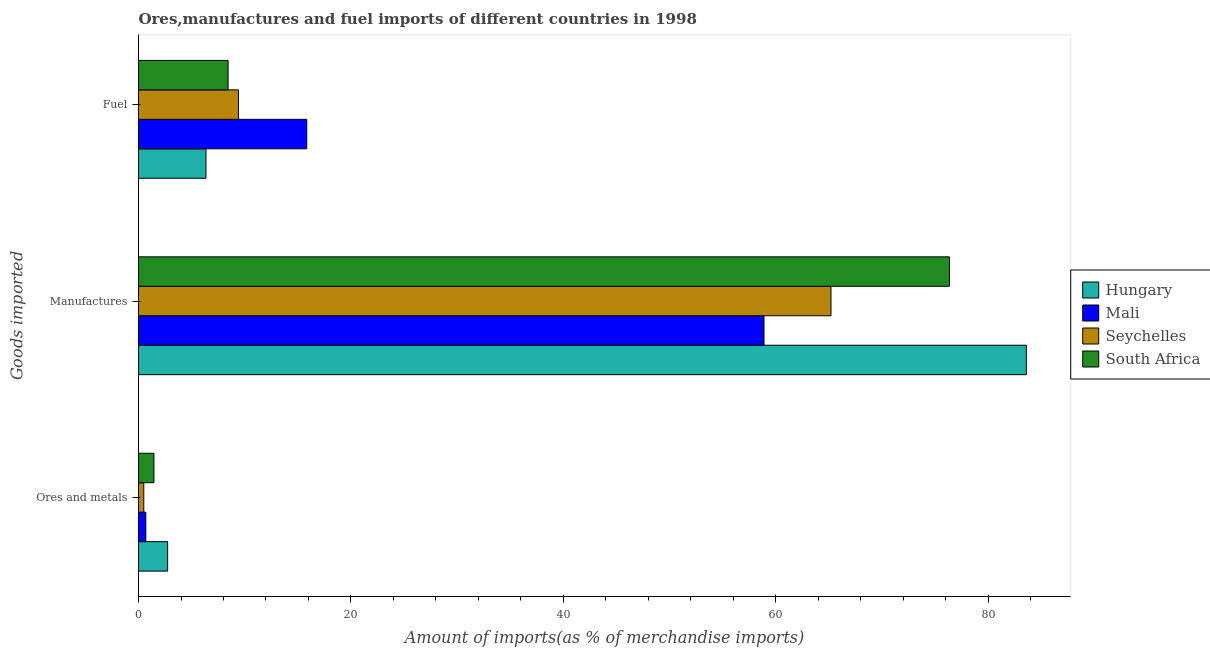Are the number of bars per tick equal to the number of legend labels?
Give a very brief answer. Yes. Are the number of bars on each tick of the Y-axis equal?
Provide a short and direct response. Yes. How many bars are there on the 3rd tick from the bottom?
Ensure brevity in your answer.  4. What is the label of the 1st group of bars from the top?
Provide a succinct answer. Fuel. What is the percentage of fuel imports in Mali?
Your answer should be very brief. 15.84. Across all countries, what is the maximum percentage of fuel imports?
Make the answer very short. 15.84. Across all countries, what is the minimum percentage of manufactures imports?
Your response must be concise. 58.89. In which country was the percentage of ores and metals imports maximum?
Offer a very short reply. Hungary. In which country was the percentage of fuel imports minimum?
Your response must be concise. Hungary. What is the total percentage of fuel imports in the graph?
Make the answer very short. 40.03. What is the difference between the percentage of manufactures imports in Seychelles and that in Hungary?
Offer a very short reply. -18.39. What is the difference between the percentage of fuel imports in South Africa and the percentage of ores and metals imports in Seychelles?
Your answer should be very brief. 7.94. What is the average percentage of ores and metals imports per country?
Offer a very short reply. 1.34. What is the difference between the percentage of ores and metals imports and percentage of fuel imports in Hungary?
Ensure brevity in your answer.  -3.61. What is the ratio of the percentage of fuel imports in Hungary to that in Mali?
Provide a short and direct response. 0.4. What is the difference between the highest and the second highest percentage of manufactures imports?
Make the answer very short. 7.24. What is the difference between the highest and the lowest percentage of ores and metals imports?
Provide a succinct answer. 2.24. In how many countries, is the percentage of fuel imports greater than the average percentage of fuel imports taken over all countries?
Your response must be concise. 1. What does the 4th bar from the top in Fuel represents?
Make the answer very short. Hungary. What does the 4th bar from the bottom in Manufactures represents?
Offer a terse response. South Africa. Is it the case that in every country, the sum of the percentage of ores and metals imports and percentage of manufactures imports is greater than the percentage of fuel imports?
Keep it short and to the point. Yes. How many bars are there?
Offer a terse response. 12. How many countries are there in the graph?
Keep it short and to the point. 4. What is the difference between two consecutive major ticks on the X-axis?
Make the answer very short. 20. Where does the legend appear in the graph?
Give a very brief answer. Center right. How many legend labels are there?
Give a very brief answer. 4. How are the legend labels stacked?
Your answer should be compact. Vertical. What is the title of the graph?
Offer a very short reply. Ores,manufactures and fuel imports of different countries in 1998. Does "Arab World" appear as one of the legend labels in the graph?
Your response must be concise. No. What is the label or title of the X-axis?
Provide a short and direct response. Amount of imports(as % of merchandise imports). What is the label or title of the Y-axis?
Provide a short and direct response. Goods imported. What is the Amount of imports(as % of merchandise imports) in Hungary in Ores and metals?
Give a very brief answer. 2.74. What is the Amount of imports(as % of merchandise imports) in Mali in Ores and metals?
Your answer should be compact. 0.69. What is the Amount of imports(as % of merchandise imports) of Seychelles in Ores and metals?
Offer a terse response. 0.5. What is the Amount of imports(as % of merchandise imports) in South Africa in Ores and metals?
Offer a terse response. 1.45. What is the Amount of imports(as % of merchandise imports) in Hungary in Manufactures?
Keep it short and to the point. 83.59. What is the Amount of imports(as % of merchandise imports) in Mali in Manufactures?
Provide a short and direct response. 58.89. What is the Amount of imports(as % of merchandise imports) in Seychelles in Manufactures?
Your answer should be very brief. 65.19. What is the Amount of imports(as % of merchandise imports) of South Africa in Manufactures?
Offer a very short reply. 76.35. What is the Amount of imports(as % of merchandise imports) in Hungary in Fuel?
Give a very brief answer. 6.35. What is the Amount of imports(as % of merchandise imports) in Mali in Fuel?
Provide a succinct answer. 15.84. What is the Amount of imports(as % of merchandise imports) of Seychelles in Fuel?
Your answer should be compact. 9.41. What is the Amount of imports(as % of merchandise imports) in South Africa in Fuel?
Provide a succinct answer. 8.43. Across all Goods imported, what is the maximum Amount of imports(as % of merchandise imports) of Hungary?
Offer a very short reply. 83.59. Across all Goods imported, what is the maximum Amount of imports(as % of merchandise imports) in Mali?
Offer a terse response. 58.89. Across all Goods imported, what is the maximum Amount of imports(as % of merchandise imports) of Seychelles?
Offer a terse response. 65.19. Across all Goods imported, what is the maximum Amount of imports(as % of merchandise imports) of South Africa?
Your answer should be very brief. 76.35. Across all Goods imported, what is the minimum Amount of imports(as % of merchandise imports) of Hungary?
Your response must be concise. 2.74. Across all Goods imported, what is the minimum Amount of imports(as % of merchandise imports) in Mali?
Your answer should be very brief. 0.69. Across all Goods imported, what is the minimum Amount of imports(as % of merchandise imports) in Seychelles?
Your answer should be very brief. 0.5. Across all Goods imported, what is the minimum Amount of imports(as % of merchandise imports) in South Africa?
Your answer should be compact. 1.45. What is the total Amount of imports(as % of merchandise imports) of Hungary in the graph?
Ensure brevity in your answer.  92.68. What is the total Amount of imports(as % of merchandise imports) in Mali in the graph?
Offer a terse response. 75.42. What is the total Amount of imports(as % of merchandise imports) in Seychelles in the graph?
Offer a very short reply. 75.1. What is the total Amount of imports(as % of merchandise imports) of South Africa in the graph?
Your answer should be compact. 86.23. What is the difference between the Amount of imports(as % of merchandise imports) of Hungary in Ores and metals and that in Manufactures?
Offer a terse response. -80.84. What is the difference between the Amount of imports(as % of merchandise imports) of Mali in Ores and metals and that in Manufactures?
Provide a short and direct response. -58.2. What is the difference between the Amount of imports(as % of merchandise imports) in Seychelles in Ores and metals and that in Manufactures?
Ensure brevity in your answer.  -64.7. What is the difference between the Amount of imports(as % of merchandise imports) of South Africa in Ores and metals and that in Manufactures?
Offer a very short reply. -74.89. What is the difference between the Amount of imports(as % of merchandise imports) of Hungary in Ores and metals and that in Fuel?
Offer a terse response. -3.61. What is the difference between the Amount of imports(as % of merchandise imports) of Mali in Ores and metals and that in Fuel?
Your answer should be compact. -15.15. What is the difference between the Amount of imports(as % of merchandise imports) of Seychelles in Ores and metals and that in Fuel?
Offer a terse response. -8.91. What is the difference between the Amount of imports(as % of merchandise imports) in South Africa in Ores and metals and that in Fuel?
Your answer should be compact. -6.98. What is the difference between the Amount of imports(as % of merchandise imports) in Hungary in Manufactures and that in Fuel?
Your response must be concise. 77.23. What is the difference between the Amount of imports(as % of merchandise imports) in Mali in Manufactures and that in Fuel?
Provide a short and direct response. 43.05. What is the difference between the Amount of imports(as % of merchandise imports) in Seychelles in Manufactures and that in Fuel?
Keep it short and to the point. 55.79. What is the difference between the Amount of imports(as % of merchandise imports) of South Africa in Manufactures and that in Fuel?
Ensure brevity in your answer.  67.91. What is the difference between the Amount of imports(as % of merchandise imports) of Hungary in Ores and metals and the Amount of imports(as % of merchandise imports) of Mali in Manufactures?
Give a very brief answer. -56.15. What is the difference between the Amount of imports(as % of merchandise imports) of Hungary in Ores and metals and the Amount of imports(as % of merchandise imports) of Seychelles in Manufactures?
Keep it short and to the point. -62.45. What is the difference between the Amount of imports(as % of merchandise imports) in Hungary in Ores and metals and the Amount of imports(as % of merchandise imports) in South Africa in Manufactures?
Your answer should be very brief. -73.6. What is the difference between the Amount of imports(as % of merchandise imports) in Mali in Ores and metals and the Amount of imports(as % of merchandise imports) in Seychelles in Manufactures?
Offer a terse response. -64.51. What is the difference between the Amount of imports(as % of merchandise imports) in Mali in Ores and metals and the Amount of imports(as % of merchandise imports) in South Africa in Manufactures?
Your response must be concise. -75.66. What is the difference between the Amount of imports(as % of merchandise imports) in Seychelles in Ores and metals and the Amount of imports(as % of merchandise imports) in South Africa in Manufactures?
Your answer should be compact. -75.85. What is the difference between the Amount of imports(as % of merchandise imports) in Hungary in Ores and metals and the Amount of imports(as % of merchandise imports) in Mali in Fuel?
Your answer should be very brief. -13.1. What is the difference between the Amount of imports(as % of merchandise imports) in Hungary in Ores and metals and the Amount of imports(as % of merchandise imports) in Seychelles in Fuel?
Give a very brief answer. -6.67. What is the difference between the Amount of imports(as % of merchandise imports) in Hungary in Ores and metals and the Amount of imports(as % of merchandise imports) in South Africa in Fuel?
Keep it short and to the point. -5.69. What is the difference between the Amount of imports(as % of merchandise imports) in Mali in Ores and metals and the Amount of imports(as % of merchandise imports) in Seychelles in Fuel?
Offer a very short reply. -8.72. What is the difference between the Amount of imports(as % of merchandise imports) of Mali in Ores and metals and the Amount of imports(as % of merchandise imports) of South Africa in Fuel?
Provide a short and direct response. -7.75. What is the difference between the Amount of imports(as % of merchandise imports) in Seychelles in Ores and metals and the Amount of imports(as % of merchandise imports) in South Africa in Fuel?
Make the answer very short. -7.94. What is the difference between the Amount of imports(as % of merchandise imports) in Hungary in Manufactures and the Amount of imports(as % of merchandise imports) in Mali in Fuel?
Offer a very short reply. 67.74. What is the difference between the Amount of imports(as % of merchandise imports) in Hungary in Manufactures and the Amount of imports(as % of merchandise imports) in Seychelles in Fuel?
Make the answer very short. 74.18. What is the difference between the Amount of imports(as % of merchandise imports) of Hungary in Manufactures and the Amount of imports(as % of merchandise imports) of South Africa in Fuel?
Offer a very short reply. 75.15. What is the difference between the Amount of imports(as % of merchandise imports) of Mali in Manufactures and the Amount of imports(as % of merchandise imports) of Seychelles in Fuel?
Provide a succinct answer. 49.48. What is the difference between the Amount of imports(as % of merchandise imports) of Mali in Manufactures and the Amount of imports(as % of merchandise imports) of South Africa in Fuel?
Make the answer very short. 50.45. What is the difference between the Amount of imports(as % of merchandise imports) of Seychelles in Manufactures and the Amount of imports(as % of merchandise imports) of South Africa in Fuel?
Offer a terse response. 56.76. What is the average Amount of imports(as % of merchandise imports) of Hungary per Goods imported?
Provide a succinct answer. 30.89. What is the average Amount of imports(as % of merchandise imports) of Mali per Goods imported?
Offer a terse response. 25.14. What is the average Amount of imports(as % of merchandise imports) in Seychelles per Goods imported?
Offer a terse response. 25.03. What is the average Amount of imports(as % of merchandise imports) of South Africa per Goods imported?
Give a very brief answer. 28.74. What is the difference between the Amount of imports(as % of merchandise imports) in Hungary and Amount of imports(as % of merchandise imports) in Mali in Ores and metals?
Offer a terse response. 2.05. What is the difference between the Amount of imports(as % of merchandise imports) of Hungary and Amount of imports(as % of merchandise imports) of Seychelles in Ores and metals?
Your response must be concise. 2.24. What is the difference between the Amount of imports(as % of merchandise imports) in Hungary and Amount of imports(as % of merchandise imports) in South Africa in Ores and metals?
Make the answer very short. 1.29. What is the difference between the Amount of imports(as % of merchandise imports) in Mali and Amount of imports(as % of merchandise imports) in Seychelles in Ores and metals?
Your response must be concise. 0.19. What is the difference between the Amount of imports(as % of merchandise imports) of Mali and Amount of imports(as % of merchandise imports) of South Africa in Ores and metals?
Provide a short and direct response. -0.76. What is the difference between the Amount of imports(as % of merchandise imports) in Seychelles and Amount of imports(as % of merchandise imports) in South Africa in Ores and metals?
Your response must be concise. -0.96. What is the difference between the Amount of imports(as % of merchandise imports) in Hungary and Amount of imports(as % of merchandise imports) in Mali in Manufactures?
Provide a short and direct response. 24.7. What is the difference between the Amount of imports(as % of merchandise imports) in Hungary and Amount of imports(as % of merchandise imports) in Seychelles in Manufactures?
Provide a short and direct response. 18.39. What is the difference between the Amount of imports(as % of merchandise imports) in Hungary and Amount of imports(as % of merchandise imports) in South Africa in Manufactures?
Ensure brevity in your answer.  7.24. What is the difference between the Amount of imports(as % of merchandise imports) of Mali and Amount of imports(as % of merchandise imports) of Seychelles in Manufactures?
Your response must be concise. -6.31. What is the difference between the Amount of imports(as % of merchandise imports) in Mali and Amount of imports(as % of merchandise imports) in South Africa in Manufactures?
Your response must be concise. -17.46. What is the difference between the Amount of imports(as % of merchandise imports) of Seychelles and Amount of imports(as % of merchandise imports) of South Africa in Manufactures?
Offer a very short reply. -11.15. What is the difference between the Amount of imports(as % of merchandise imports) in Hungary and Amount of imports(as % of merchandise imports) in Mali in Fuel?
Keep it short and to the point. -9.49. What is the difference between the Amount of imports(as % of merchandise imports) of Hungary and Amount of imports(as % of merchandise imports) of Seychelles in Fuel?
Provide a short and direct response. -3.06. What is the difference between the Amount of imports(as % of merchandise imports) in Hungary and Amount of imports(as % of merchandise imports) in South Africa in Fuel?
Ensure brevity in your answer.  -2.08. What is the difference between the Amount of imports(as % of merchandise imports) in Mali and Amount of imports(as % of merchandise imports) in Seychelles in Fuel?
Your response must be concise. 6.43. What is the difference between the Amount of imports(as % of merchandise imports) of Mali and Amount of imports(as % of merchandise imports) of South Africa in Fuel?
Give a very brief answer. 7.41. What is the difference between the Amount of imports(as % of merchandise imports) in Seychelles and Amount of imports(as % of merchandise imports) in South Africa in Fuel?
Ensure brevity in your answer.  0.97. What is the ratio of the Amount of imports(as % of merchandise imports) in Hungary in Ores and metals to that in Manufactures?
Offer a very short reply. 0.03. What is the ratio of the Amount of imports(as % of merchandise imports) in Mali in Ores and metals to that in Manufactures?
Offer a terse response. 0.01. What is the ratio of the Amount of imports(as % of merchandise imports) in Seychelles in Ores and metals to that in Manufactures?
Give a very brief answer. 0.01. What is the ratio of the Amount of imports(as % of merchandise imports) of South Africa in Ores and metals to that in Manufactures?
Your response must be concise. 0.02. What is the ratio of the Amount of imports(as % of merchandise imports) of Hungary in Ores and metals to that in Fuel?
Offer a very short reply. 0.43. What is the ratio of the Amount of imports(as % of merchandise imports) in Mali in Ores and metals to that in Fuel?
Offer a terse response. 0.04. What is the ratio of the Amount of imports(as % of merchandise imports) of Seychelles in Ores and metals to that in Fuel?
Your answer should be very brief. 0.05. What is the ratio of the Amount of imports(as % of merchandise imports) in South Africa in Ores and metals to that in Fuel?
Your answer should be very brief. 0.17. What is the ratio of the Amount of imports(as % of merchandise imports) of Hungary in Manufactures to that in Fuel?
Ensure brevity in your answer.  13.16. What is the ratio of the Amount of imports(as % of merchandise imports) in Mali in Manufactures to that in Fuel?
Provide a short and direct response. 3.72. What is the ratio of the Amount of imports(as % of merchandise imports) in Seychelles in Manufactures to that in Fuel?
Offer a terse response. 6.93. What is the ratio of the Amount of imports(as % of merchandise imports) in South Africa in Manufactures to that in Fuel?
Ensure brevity in your answer.  9.05. What is the difference between the highest and the second highest Amount of imports(as % of merchandise imports) of Hungary?
Make the answer very short. 77.23. What is the difference between the highest and the second highest Amount of imports(as % of merchandise imports) in Mali?
Your response must be concise. 43.05. What is the difference between the highest and the second highest Amount of imports(as % of merchandise imports) of Seychelles?
Give a very brief answer. 55.79. What is the difference between the highest and the second highest Amount of imports(as % of merchandise imports) of South Africa?
Keep it short and to the point. 67.91. What is the difference between the highest and the lowest Amount of imports(as % of merchandise imports) of Hungary?
Keep it short and to the point. 80.84. What is the difference between the highest and the lowest Amount of imports(as % of merchandise imports) in Mali?
Provide a succinct answer. 58.2. What is the difference between the highest and the lowest Amount of imports(as % of merchandise imports) in Seychelles?
Make the answer very short. 64.7. What is the difference between the highest and the lowest Amount of imports(as % of merchandise imports) in South Africa?
Your response must be concise. 74.89. 